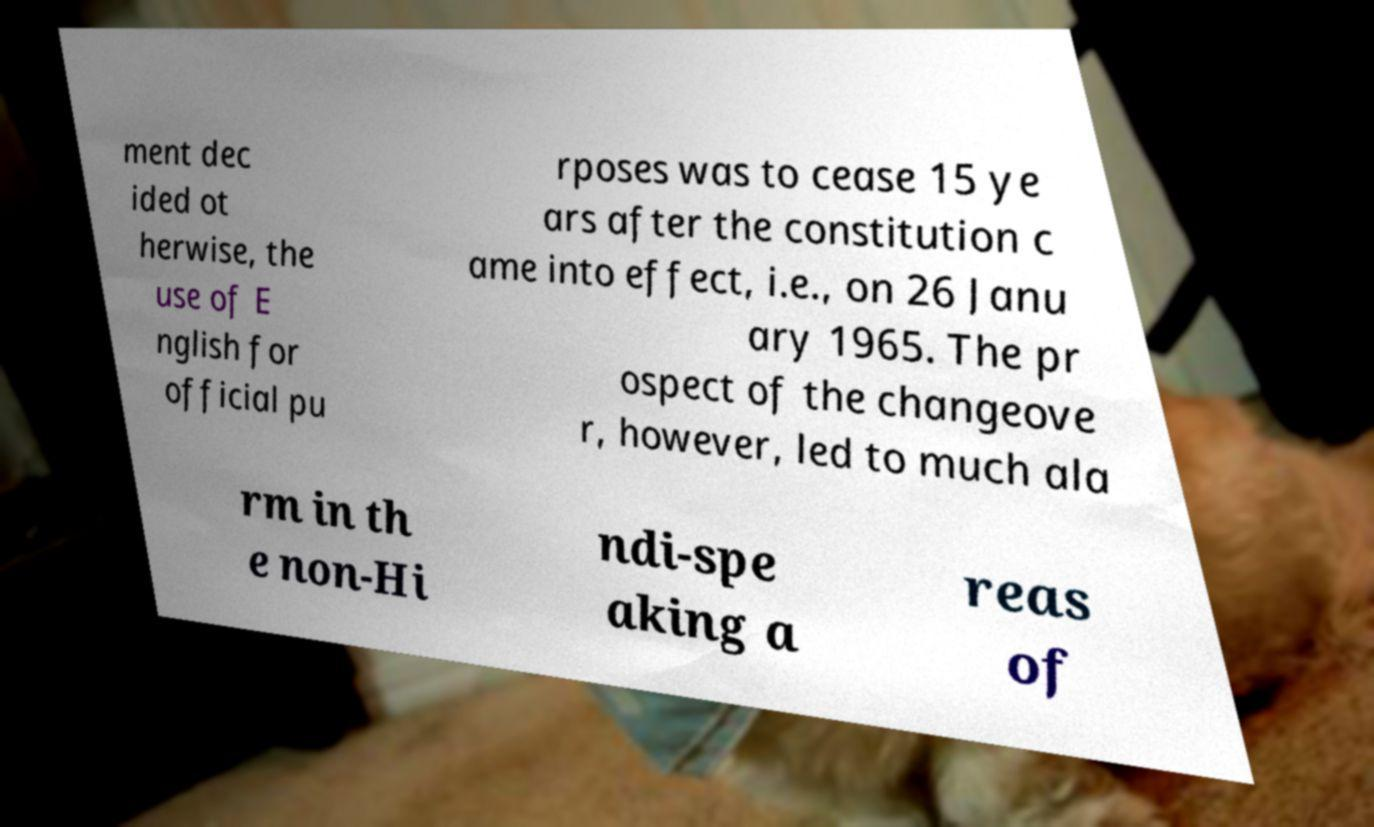Please read and relay the text visible in this image. What does it say? ment dec ided ot herwise, the use of E nglish for official pu rposes was to cease 15 ye ars after the constitution c ame into effect, i.e., on 26 Janu ary 1965. The pr ospect of the changeove r, however, led to much ala rm in th e non-Hi ndi-spe aking a reas of 